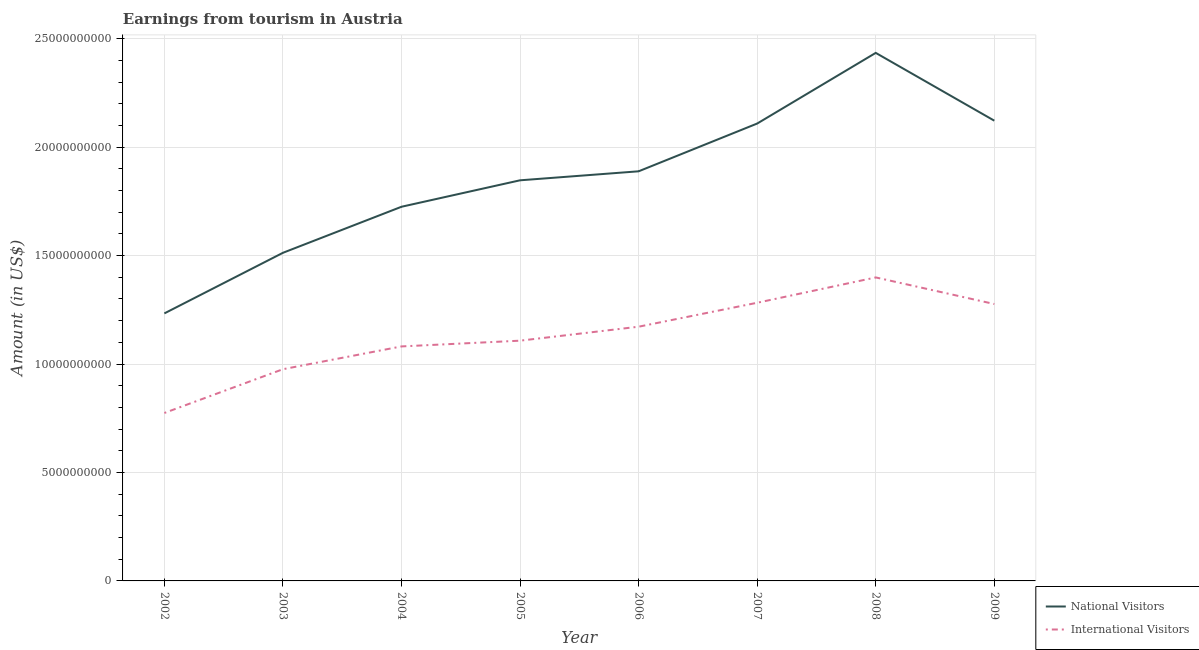Does the line corresponding to amount earned from international visitors intersect with the line corresponding to amount earned from national visitors?
Your answer should be compact. No. What is the amount earned from national visitors in 2003?
Your answer should be very brief. 1.51e+1. Across all years, what is the maximum amount earned from international visitors?
Ensure brevity in your answer.  1.40e+1. Across all years, what is the minimum amount earned from national visitors?
Keep it short and to the point. 1.23e+1. In which year was the amount earned from national visitors maximum?
Your answer should be very brief. 2008. What is the total amount earned from international visitors in the graph?
Your response must be concise. 9.07e+1. What is the difference between the amount earned from international visitors in 2005 and that in 2008?
Offer a very short reply. -2.92e+09. What is the difference between the amount earned from national visitors in 2006 and the amount earned from international visitors in 2008?
Keep it short and to the point. 4.89e+09. What is the average amount earned from international visitors per year?
Your answer should be very brief. 1.13e+1. In the year 2008, what is the difference between the amount earned from international visitors and amount earned from national visitors?
Your answer should be very brief. -1.04e+1. In how many years, is the amount earned from international visitors greater than 12000000000 US$?
Offer a very short reply. 3. What is the ratio of the amount earned from international visitors in 2003 to that in 2006?
Keep it short and to the point. 0.83. Is the difference between the amount earned from international visitors in 2003 and 2008 greater than the difference between the amount earned from national visitors in 2003 and 2008?
Your response must be concise. Yes. What is the difference between the highest and the second highest amount earned from national visitors?
Offer a terse response. 3.13e+09. What is the difference between the highest and the lowest amount earned from international visitors?
Offer a terse response. 6.25e+09. In how many years, is the amount earned from international visitors greater than the average amount earned from international visitors taken over all years?
Make the answer very short. 4. Is the sum of the amount earned from national visitors in 2005 and 2008 greater than the maximum amount earned from international visitors across all years?
Ensure brevity in your answer.  Yes. Is the amount earned from international visitors strictly less than the amount earned from national visitors over the years?
Offer a very short reply. Yes. How many lines are there?
Your response must be concise. 2. How many years are there in the graph?
Your response must be concise. 8. Does the graph contain grids?
Offer a terse response. Yes. Where does the legend appear in the graph?
Your answer should be compact. Bottom right. How many legend labels are there?
Offer a very short reply. 2. What is the title of the graph?
Give a very brief answer. Earnings from tourism in Austria. Does "IMF nonconcessional" appear as one of the legend labels in the graph?
Your answer should be compact. No. What is the label or title of the X-axis?
Provide a succinct answer. Year. What is the Amount (in US$) in National Visitors in 2002?
Offer a very short reply. 1.23e+1. What is the Amount (in US$) in International Visitors in 2002?
Offer a terse response. 7.74e+09. What is the Amount (in US$) of National Visitors in 2003?
Keep it short and to the point. 1.51e+1. What is the Amount (in US$) of International Visitors in 2003?
Offer a very short reply. 9.76e+09. What is the Amount (in US$) in National Visitors in 2004?
Ensure brevity in your answer.  1.73e+1. What is the Amount (in US$) of International Visitors in 2004?
Ensure brevity in your answer.  1.08e+1. What is the Amount (in US$) in National Visitors in 2005?
Offer a terse response. 1.85e+1. What is the Amount (in US$) in International Visitors in 2005?
Ensure brevity in your answer.  1.11e+1. What is the Amount (in US$) in National Visitors in 2006?
Provide a short and direct response. 1.89e+1. What is the Amount (in US$) in International Visitors in 2006?
Give a very brief answer. 1.17e+1. What is the Amount (in US$) in National Visitors in 2007?
Provide a succinct answer. 2.11e+1. What is the Amount (in US$) of International Visitors in 2007?
Provide a succinct answer. 1.28e+1. What is the Amount (in US$) in National Visitors in 2008?
Ensure brevity in your answer.  2.43e+1. What is the Amount (in US$) in International Visitors in 2008?
Keep it short and to the point. 1.40e+1. What is the Amount (in US$) of National Visitors in 2009?
Offer a very short reply. 2.12e+1. What is the Amount (in US$) of International Visitors in 2009?
Give a very brief answer. 1.28e+1. Across all years, what is the maximum Amount (in US$) of National Visitors?
Give a very brief answer. 2.43e+1. Across all years, what is the maximum Amount (in US$) of International Visitors?
Provide a succinct answer. 1.40e+1. Across all years, what is the minimum Amount (in US$) of National Visitors?
Provide a short and direct response. 1.23e+1. Across all years, what is the minimum Amount (in US$) of International Visitors?
Provide a short and direct response. 7.74e+09. What is the total Amount (in US$) in National Visitors in the graph?
Your answer should be compact. 1.49e+11. What is the total Amount (in US$) of International Visitors in the graph?
Provide a succinct answer. 9.07e+1. What is the difference between the Amount (in US$) of National Visitors in 2002 and that in 2003?
Offer a very short reply. -2.79e+09. What is the difference between the Amount (in US$) in International Visitors in 2002 and that in 2003?
Ensure brevity in your answer.  -2.02e+09. What is the difference between the Amount (in US$) of National Visitors in 2002 and that in 2004?
Give a very brief answer. -4.92e+09. What is the difference between the Amount (in US$) of International Visitors in 2002 and that in 2004?
Your answer should be very brief. -3.07e+09. What is the difference between the Amount (in US$) of National Visitors in 2002 and that in 2005?
Keep it short and to the point. -6.14e+09. What is the difference between the Amount (in US$) in International Visitors in 2002 and that in 2005?
Offer a terse response. -3.33e+09. What is the difference between the Amount (in US$) of National Visitors in 2002 and that in 2006?
Keep it short and to the point. -6.55e+09. What is the difference between the Amount (in US$) in International Visitors in 2002 and that in 2006?
Ensure brevity in your answer.  -3.98e+09. What is the difference between the Amount (in US$) in National Visitors in 2002 and that in 2007?
Provide a succinct answer. -8.75e+09. What is the difference between the Amount (in US$) of International Visitors in 2002 and that in 2007?
Offer a very short reply. -5.08e+09. What is the difference between the Amount (in US$) of National Visitors in 2002 and that in 2008?
Provide a succinct answer. -1.20e+1. What is the difference between the Amount (in US$) of International Visitors in 2002 and that in 2008?
Make the answer very short. -6.25e+09. What is the difference between the Amount (in US$) in National Visitors in 2002 and that in 2009?
Your answer should be very brief. -8.89e+09. What is the difference between the Amount (in US$) in International Visitors in 2002 and that in 2009?
Provide a short and direct response. -5.02e+09. What is the difference between the Amount (in US$) in National Visitors in 2003 and that in 2004?
Offer a terse response. -2.12e+09. What is the difference between the Amount (in US$) of International Visitors in 2003 and that in 2004?
Offer a terse response. -1.05e+09. What is the difference between the Amount (in US$) of National Visitors in 2003 and that in 2005?
Your answer should be very brief. -3.34e+09. What is the difference between the Amount (in US$) in International Visitors in 2003 and that in 2005?
Provide a short and direct response. -1.32e+09. What is the difference between the Amount (in US$) in National Visitors in 2003 and that in 2006?
Ensure brevity in your answer.  -3.76e+09. What is the difference between the Amount (in US$) of International Visitors in 2003 and that in 2006?
Offer a very short reply. -1.96e+09. What is the difference between the Amount (in US$) in National Visitors in 2003 and that in 2007?
Make the answer very short. -5.96e+09. What is the difference between the Amount (in US$) of International Visitors in 2003 and that in 2007?
Ensure brevity in your answer.  -3.06e+09. What is the difference between the Amount (in US$) of National Visitors in 2003 and that in 2008?
Ensure brevity in your answer.  -9.22e+09. What is the difference between the Amount (in US$) in International Visitors in 2003 and that in 2008?
Your answer should be compact. -4.23e+09. What is the difference between the Amount (in US$) of National Visitors in 2003 and that in 2009?
Provide a short and direct response. -6.09e+09. What is the difference between the Amount (in US$) of International Visitors in 2003 and that in 2009?
Ensure brevity in your answer.  -3.01e+09. What is the difference between the Amount (in US$) of National Visitors in 2004 and that in 2005?
Offer a very short reply. -1.22e+09. What is the difference between the Amount (in US$) of International Visitors in 2004 and that in 2005?
Keep it short and to the point. -2.65e+08. What is the difference between the Amount (in US$) in National Visitors in 2004 and that in 2006?
Provide a succinct answer. -1.64e+09. What is the difference between the Amount (in US$) in International Visitors in 2004 and that in 2006?
Your response must be concise. -9.09e+08. What is the difference between the Amount (in US$) in National Visitors in 2004 and that in 2007?
Provide a short and direct response. -3.84e+09. What is the difference between the Amount (in US$) of International Visitors in 2004 and that in 2007?
Make the answer very short. -2.01e+09. What is the difference between the Amount (in US$) of National Visitors in 2004 and that in 2008?
Give a very brief answer. -7.10e+09. What is the difference between the Amount (in US$) in International Visitors in 2004 and that in 2008?
Provide a succinct answer. -3.18e+09. What is the difference between the Amount (in US$) in National Visitors in 2004 and that in 2009?
Offer a very short reply. -3.97e+09. What is the difference between the Amount (in US$) in International Visitors in 2004 and that in 2009?
Offer a very short reply. -1.96e+09. What is the difference between the Amount (in US$) in National Visitors in 2005 and that in 2006?
Provide a succinct answer. -4.15e+08. What is the difference between the Amount (in US$) of International Visitors in 2005 and that in 2006?
Your answer should be very brief. -6.44e+08. What is the difference between the Amount (in US$) in National Visitors in 2005 and that in 2007?
Offer a very short reply. -2.62e+09. What is the difference between the Amount (in US$) in International Visitors in 2005 and that in 2007?
Make the answer very short. -1.75e+09. What is the difference between the Amount (in US$) of National Visitors in 2005 and that in 2008?
Your answer should be very brief. -5.88e+09. What is the difference between the Amount (in US$) of International Visitors in 2005 and that in 2008?
Your answer should be compact. -2.92e+09. What is the difference between the Amount (in US$) in National Visitors in 2005 and that in 2009?
Give a very brief answer. -2.75e+09. What is the difference between the Amount (in US$) of International Visitors in 2005 and that in 2009?
Your response must be concise. -1.69e+09. What is the difference between the Amount (in US$) of National Visitors in 2006 and that in 2007?
Provide a short and direct response. -2.20e+09. What is the difference between the Amount (in US$) of International Visitors in 2006 and that in 2007?
Make the answer very short. -1.10e+09. What is the difference between the Amount (in US$) in National Visitors in 2006 and that in 2008?
Make the answer very short. -5.46e+09. What is the difference between the Amount (in US$) of International Visitors in 2006 and that in 2008?
Your response must be concise. -2.27e+09. What is the difference between the Amount (in US$) in National Visitors in 2006 and that in 2009?
Ensure brevity in your answer.  -2.33e+09. What is the difference between the Amount (in US$) in International Visitors in 2006 and that in 2009?
Your answer should be very brief. -1.05e+09. What is the difference between the Amount (in US$) of National Visitors in 2007 and that in 2008?
Provide a short and direct response. -3.26e+09. What is the difference between the Amount (in US$) in International Visitors in 2007 and that in 2008?
Your answer should be compact. -1.17e+09. What is the difference between the Amount (in US$) of National Visitors in 2007 and that in 2009?
Provide a short and direct response. -1.32e+08. What is the difference between the Amount (in US$) in International Visitors in 2007 and that in 2009?
Provide a succinct answer. 5.80e+07. What is the difference between the Amount (in US$) of National Visitors in 2008 and that in 2009?
Offer a very short reply. 3.13e+09. What is the difference between the Amount (in US$) of International Visitors in 2008 and that in 2009?
Ensure brevity in your answer.  1.23e+09. What is the difference between the Amount (in US$) of National Visitors in 2002 and the Amount (in US$) of International Visitors in 2003?
Make the answer very short. 2.57e+09. What is the difference between the Amount (in US$) in National Visitors in 2002 and the Amount (in US$) in International Visitors in 2004?
Ensure brevity in your answer.  1.52e+09. What is the difference between the Amount (in US$) of National Visitors in 2002 and the Amount (in US$) of International Visitors in 2005?
Your answer should be very brief. 1.26e+09. What is the difference between the Amount (in US$) in National Visitors in 2002 and the Amount (in US$) in International Visitors in 2006?
Your response must be concise. 6.13e+08. What is the difference between the Amount (in US$) of National Visitors in 2002 and the Amount (in US$) of International Visitors in 2007?
Provide a short and direct response. -4.91e+08. What is the difference between the Amount (in US$) of National Visitors in 2002 and the Amount (in US$) of International Visitors in 2008?
Make the answer very short. -1.66e+09. What is the difference between the Amount (in US$) in National Visitors in 2002 and the Amount (in US$) in International Visitors in 2009?
Your response must be concise. -4.33e+08. What is the difference between the Amount (in US$) in National Visitors in 2003 and the Amount (in US$) in International Visitors in 2004?
Your answer should be very brief. 4.32e+09. What is the difference between the Amount (in US$) of National Visitors in 2003 and the Amount (in US$) of International Visitors in 2005?
Provide a succinct answer. 4.05e+09. What is the difference between the Amount (in US$) in National Visitors in 2003 and the Amount (in US$) in International Visitors in 2006?
Your response must be concise. 3.41e+09. What is the difference between the Amount (in US$) of National Visitors in 2003 and the Amount (in US$) of International Visitors in 2007?
Offer a very short reply. 2.30e+09. What is the difference between the Amount (in US$) of National Visitors in 2003 and the Amount (in US$) of International Visitors in 2008?
Keep it short and to the point. 1.14e+09. What is the difference between the Amount (in US$) in National Visitors in 2003 and the Amount (in US$) in International Visitors in 2009?
Provide a short and direct response. 2.36e+09. What is the difference between the Amount (in US$) in National Visitors in 2004 and the Amount (in US$) in International Visitors in 2005?
Your answer should be compact. 6.17e+09. What is the difference between the Amount (in US$) of National Visitors in 2004 and the Amount (in US$) of International Visitors in 2006?
Make the answer very short. 5.53e+09. What is the difference between the Amount (in US$) of National Visitors in 2004 and the Amount (in US$) of International Visitors in 2007?
Offer a terse response. 4.43e+09. What is the difference between the Amount (in US$) of National Visitors in 2004 and the Amount (in US$) of International Visitors in 2008?
Offer a very short reply. 3.26e+09. What is the difference between the Amount (in US$) of National Visitors in 2004 and the Amount (in US$) of International Visitors in 2009?
Make the answer very short. 4.48e+09. What is the difference between the Amount (in US$) in National Visitors in 2005 and the Amount (in US$) in International Visitors in 2006?
Your answer should be very brief. 6.75e+09. What is the difference between the Amount (in US$) of National Visitors in 2005 and the Amount (in US$) of International Visitors in 2007?
Provide a succinct answer. 5.65e+09. What is the difference between the Amount (in US$) of National Visitors in 2005 and the Amount (in US$) of International Visitors in 2008?
Offer a terse response. 4.48e+09. What is the difference between the Amount (in US$) in National Visitors in 2005 and the Amount (in US$) in International Visitors in 2009?
Give a very brief answer. 5.70e+09. What is the difference between the Amount (in US$) of National Visitors in 2006 and the Amount (in US$) of International Visitors in 2007?
Keep it short and to the point. 6.06e+09. What is the difference between the Amount (in US$) of National Visitors in 2006 and the Amount (in US$) of International Visitors in 2008?
Provide a succinct answer. 4.89e+09. What is the difference between the Amount (in US$) in National Visitors in 2006 and the Amount (in US$) in International Visitors in 2009?
Offer a very short reply. 6.12e+09. What is the difference between the Amount (in US$) of National Visitors in 2007 and the Amount (in US$) of International Visitors in 2008?
Your answer should be compact. 7.10e+09. What is the difference between the Amount (in US$) in National Visitors in 2007 and the Amount (in US$) in International Visitors in 2009?
Make the answer very short. 8.32e+09. What is the difference between the Amount (in US$) of National Visitors in 2008 and the Amount (in US$) of International Visitors in 2009?
Provide a succinct answer. 1.16e+1. What is the average Amount (in US$) of National Visitors per year?
Provide a short and direct response. 1.86e+1. What is the average Amount (in US$) in International Visitors per year?
Give a very brief answer. 1.13e+1. In the year 2002, what is the difference between the Amount (in US$) in National Visitors and Amount (in US$) in International Visitors?
Keep it short and to the point. 4.59e+09. In the year 2003, what is the difference between the Amount (in US$) of National Visitors and Amount (in US$) of International Visitors?
Keep it short and to the point. 5.37e+09. In the year 2004, what is the difference between the Amount (in US$) of National Visitors and Amount (in US$) of International Visitors?
Offer a very short reply. 6.44e+09. In the year 2005, what is the difference between the Amount (in US$) in National Visitors and Amount (in US$) in International Visitors?
Keep it short and to the point. 7.39e+09. In the year 2006, what is the difference between the Amount (in US$) in National Visitors and Amount (in US$) in International Visitors?
Provide a succinct answer. 7.16e+09. In the year 2007, what is the difference between the Amount (in US$) of National Visitors and Amount (in US$) of International Visitors?
Your answer should be compact. 8.26e+09. In the year 2008, what is the difference between the Amount (in US$) of National Visitors and Amount (in US$) of International Visitors?
Give a very brief answer. 1.04e+1. In the year 2009, what is the difference between the Amount (in US$) of National Visitors and Amount (in US$) of International Visitors?
Ensure brevity in your answer.  8.45e+09. What is the ratio of the Amount (in US$) of National Visitors in 2002 to that in 2003?
Your response must be concise. 0.82. What is the ratio of the Amount (in US$) of International Visitors in 2002 to that in 2003?
Give a very brief answer. 0.79. What is the ratio of the Amount (in US$) in National Visitors in 2002 to that in 2004?
Keep it short and to the point. 0.71. What is the ratio of the Amount (in US$) of International Visitors in 2002 to that in 2004?
Keep it short and to the point. 0.72. What is the ratio of the Amount (in US$) of National Visitors in 2002 to that in 2005?
Your response must be concise. 0.67. What is the ratio of the Amount (in US$) of International Visitors in 2002 to that in 2005?
Your answer should be compact. 0.7. What is the ratio of the Amount (in US$) of National Visitors in 2002 to that in 2006?
Ensure brevity in your answer.  0.65. What is the ratio of the Amount (in US$) in International Visitors in 2002 to that in 2006?
Your response must be concise. 0.66. What is the ratio of the Amount (in US$) of National Visitors in 2002 to that in 2007?
Give a very brief answer. 0.58. What is the ratio of the Amount (in US$) of International Visitors in 2002 to that in 2007?
Provide a succinct answer. 0.6. What is the ratio of the Amount (in US$) in National Visitors in 2002 to that in 2008?
Keep it short and to the point. 0.51. What is the ratio of the Amount (in US$) of International Visitors in 2002 to that in 2008?
Your answer should be very brief. 0.55. What is the ratio of the Amount (in US$) in National Visitors in 2002 to that in 2009?
Offer a very short reply. 0.58. What is the ratio of the Amount (in US$) in International Visitors in 2002 to that in 2009?
Offer a very short reply. 0.61. What is the ratio of the Amount (in US$) in National Visitors in 2003 to that in 2004?
Give a very brief answer. 0.88. What is the ratio of the Amount (in US$) of International Visitors in 2003 to that in 2004?
Give a very brief answer. 0.9. What is the ratio of the Amount (in US$) in National Visitors in 2003 to that in 2005?
Provide a succinct answer. 0.82. What is the ratio of the Amount (in US$) of International Visitors in 2003 to that in 2005?
Offer a very short reply. 0.88. What is the ratio of the Amount (in US$) of National Visitors in 2003 to that in 2006?
Ensure brevity in your answer.  0.8. What is the ratio of the Amount (in US$) in International Visitors in 2003 to that in 2006?
Provide a succinct answer. 0.83. What is the ratio of the Amount (in US$) of National Visitors in 2003 to that in 2007?
Provide a succinct answer. 0.72. What is the ratio of the Amount (in US$) of International Visitors in 2003 to that in 2007?
Ensure brevity in your answer.  0.76. What is the ratio of the Amount (in US$) of National Visitors in 2003 to that in 2008?
Your response must be concise. 0.62. What is the ratio of the Amount (in US$) in International Visitors in 2003 to that in 2008?
Offer a terse response. 0.7. What is the ratio of the Amount (in US$) in National Visitors in 2003 to that in 2009?
Offer a terse response. 0.71. What is the ratio of the Amount (in US$) of International Visitors in 2003 to that in 2009?
Give a very brief answer. 0.76. What is the ratio of the Amount (in US$) of National Visitors in 2004 to that in 2005?
Make the answer very short. 0.93. What is the ratio of the Amount (in US$) of International Visitors in 2004 to that in 2005?
Your response must be concise. 0.98. What is the ratio of the Amount (in US$) of National Visitors in 2004 to that in 2006?
Offer a very short reply. 0.91. What is the ratio of the Amount (in US$) of International Visitors in 2004 to that in 2006?
Keep it short and to the point. 0.92. What is the ratio of the Amount (in US$) in National Visitors in 2004 to that in 2007?
Provide a short and direct response. 0.82. What is the ratio of the Amount (in US$) in International Visitors in 2004 to that in 2007?
Offer a terse response. 0.84. What is the ratio of the Amount (in US$) in National Visitors in 2004 to that in 2008?
Provide a short and direct response. 0.71. What is the ratio of the Amount (in US$) in International Visitors in 2004 to that in 2008?
Make the answer very short. 0.77. What is the ratio of the Amount (in US$) of National Visitors in 2004 to that in 2009?
Your answer should be compact. 0.81. What is the ratio of the Amount (in US$) in International Visitors in 2004 to that in 2009?
Keep it short and to the point. 0.85. What is the ratio of the Amount (in US$) in National Visitors in 2005 to that in 2006?
Provide a short and direct response. 0.98. What is the ratio of the Amount (in US$) in International Visitors in 2005 to that in 2006?
Give a very brief answer. 0.95. What is the ratio of the Amount (in US$) in National Visitors in 2005 to that in 2007?
Your answer should be compact. 0.88. What is the ratio of the Amount (in US$) of International Visitors in 2005 to that in 2007?
Keep it short and to the point. 0.86. What is the ratio of the Amount (in US$) of National Visitors in 2005 to that in 2008?
Provide a succinct answer. 0.76. What is the ratio of the Amount (in US$) in International Visitors in 2005 to that in 2008?
Ensure brevity in your answer.  0.79. What is the ratio of the Amount (in US$) of National Visitors in 2005 to that in 2009?
Offer a very short reply. 0.87. What is the ratio of the Amount (in US$) in International Visitors in 2005 to that in 2009?
Ensure brevity in your answer.  0.87. What is the ratio of the Amount (in US$) of National Visitors in 2006 to that in 2007?
Offer a terse response. 0.9. What is the ratio of the Amount (in US$) of International Visitors in 2006 to that in 2007?
Provide a succinct answer. 0.91. What is the ratio of the Amount (in US$) of National Visitors in 2006 to that in 2008?
Offer a very short reply. 0.78. What is the ratio of the Amount (in US$) in International Visitors in 2006 to that in 2008?
Provide a succinct answer. 0.84. What is the ratio of the Amount (in US$) in National Visitors in 2006 to that in 2009?
Your answer should be compact. 0.89. What is the ratio of the Amount (in US$) of International Visitors in 2006 to that in 2009?
Provide a short and direct response. 0.92. What is the ratio of the Amount (in US$) in National Visitors in 2007 to that in 2008?
Your answer should be compact. 0.87. What is the ratio of the Amount (in US$) in International Visitors in 2007 to that in 2008?
Keep it short and to the point. 0.92. What is the ratio of the Amount (in US$) of National Visitors in 2007 to that in 2009?
Your answer should be compact. 0.99. What is the ratio of the Amount (in US$) of International Visitors in 2007 to that in 2009?
Your answer should be very brief. 1. What is the ratio of the Amount (in US$) in National Visitors in 2008 to that in 2009?
Your response must be concise. 1.15. What is the ratio of the Amount (in US$) in International Visitors in 2008 to that in 2009?
Your answer should be compact. 1.1. What is the difference between the highest and the second highest Amount (in US$) in National Visitors?
Offer a very short reply. 3.13e+09. What is the difference between the highest and the second highest Amount (in US$) of International Visitors?
Provide a succinct answer. 1.17e+09. What is the difference between the highest and the lowest Amount (in US$) of National Visitors?
Offer a very short reply. 1.20e+1. What is the difference between the highest and the lowest Amount (in US$) of International Visitors?
Keep it short and to the point. 6.25e+09. 